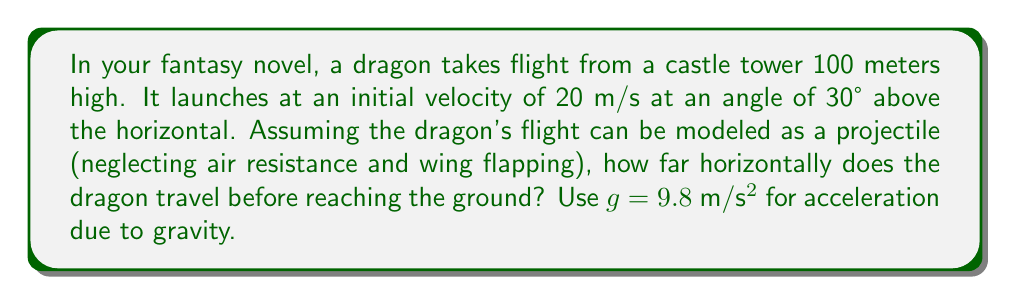Provide a solution to this math problem. To solve this problem, we'll use the projectile motion equations. Let's break it down step-by-step:

1) First, let's identify the known variables:
   - Initial height, $h_0 = 100$ m
   - Initial velocity, $v_0 = 20$ m/s
   - Angle of launch, $\theta = 30°$
   - Acceleration due to gravity, $g = 9.8$ m/s²

2) We need to find the horizontal distance, which is given by $x = v_x t$, where $t$ is the time of flight.

3) The horizontal component of velocity is constant:
   $v_x = v_0 \cos(\theta) = 20 \cos(30°) = 20 \cdot \frac{\sqrt{3}}{2} = 10\sqrt{3}$ m/s

4) To find $t$, we can use the vertical motion equation:
   $y = h_0 + v_y t - \frac{1}{2}gt^2$

   Where $v_y = v_0 \sin(\theta) = 20 \sin(30°) = 20 \cdot \frac{1}{2} = 10$ m/s

5) At the point of landing, $y = 0$. So:
   $0 = 100 + 10t - \frac{1}{2}(9.8)t^2$

6) Rearranging:
   $4.9t^2 - 10t - 100 = 0$

7) This is a quadratic equation. We can solve it using the quadratic formula:
   $t = \frac{-b \pm \sqrt{b^2 - 4ac}}{2a}$

   Where $a = 4.9$, $b = -10$, and $c = -100$

8) Solving:
   $t = \frac{10 \pm \sqrt{100 + 1960}}{9.8} = \frac{10 \pm \sqrt{2060}}{9.8}$

9) We take the positive root as time can't be negative:
   $t = \frac{10 + \sqrt{2060}}{9.8} \approx 6.84$ seconds

10) Now we can find the horizontal distance:
    $x = v_x t = 10\sqrt{3} \cdot 6.84 \approx 118.5$ meters
Answer: 118.5 meters 